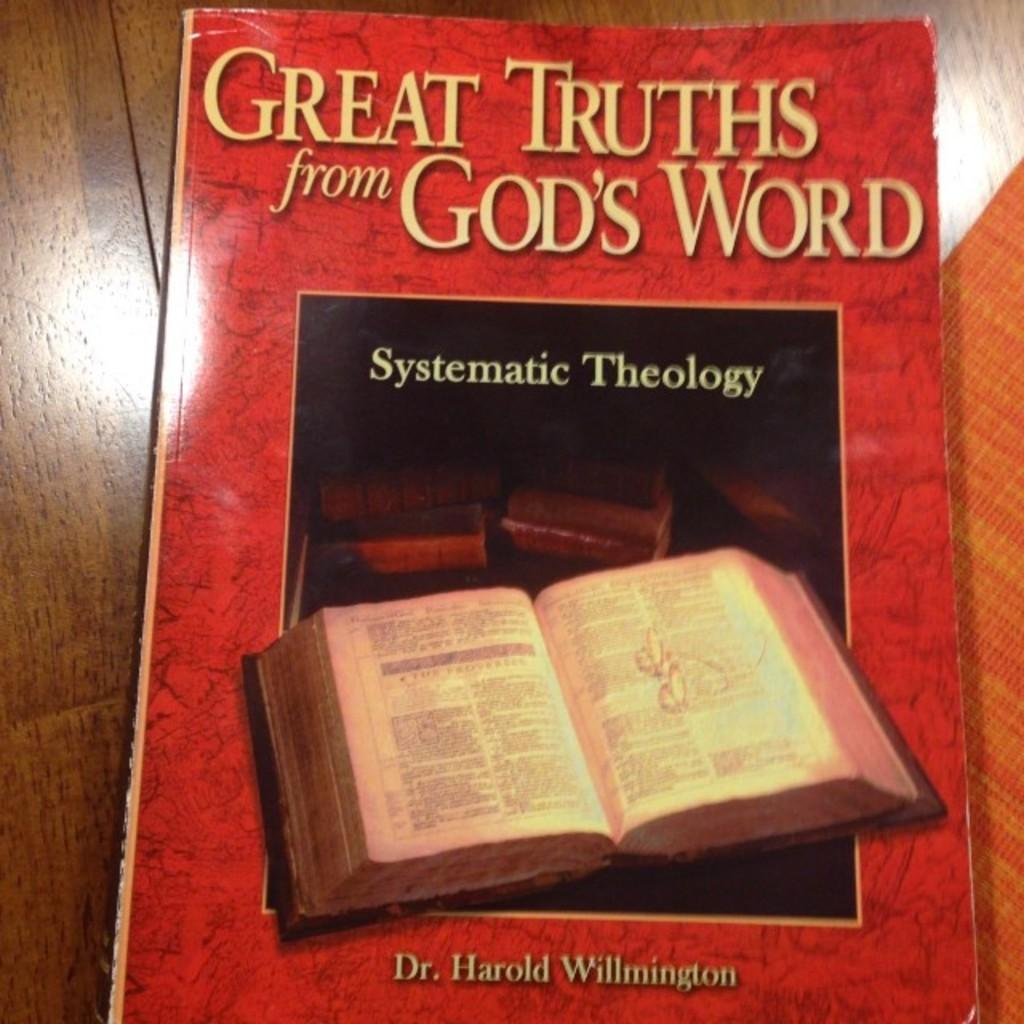What is the title of the book?
Your answer should be compact. Great truths from god's word. 